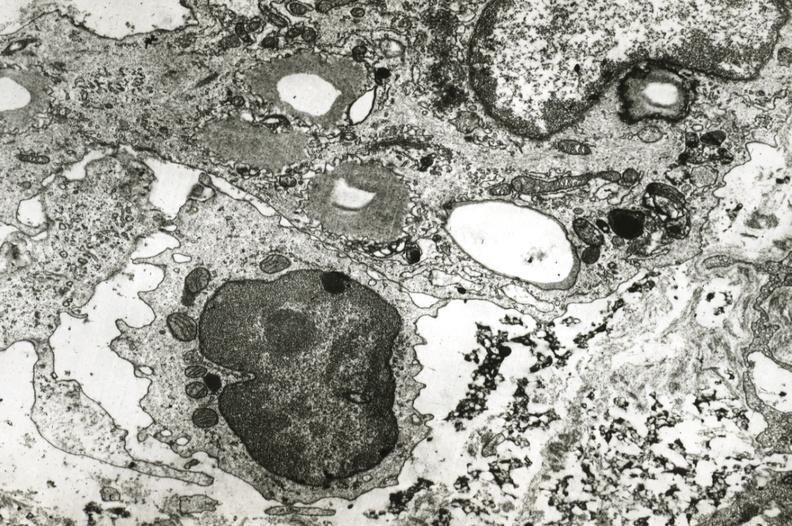s coronary artery present?
Answer the question using a single word or phrase. Yes 